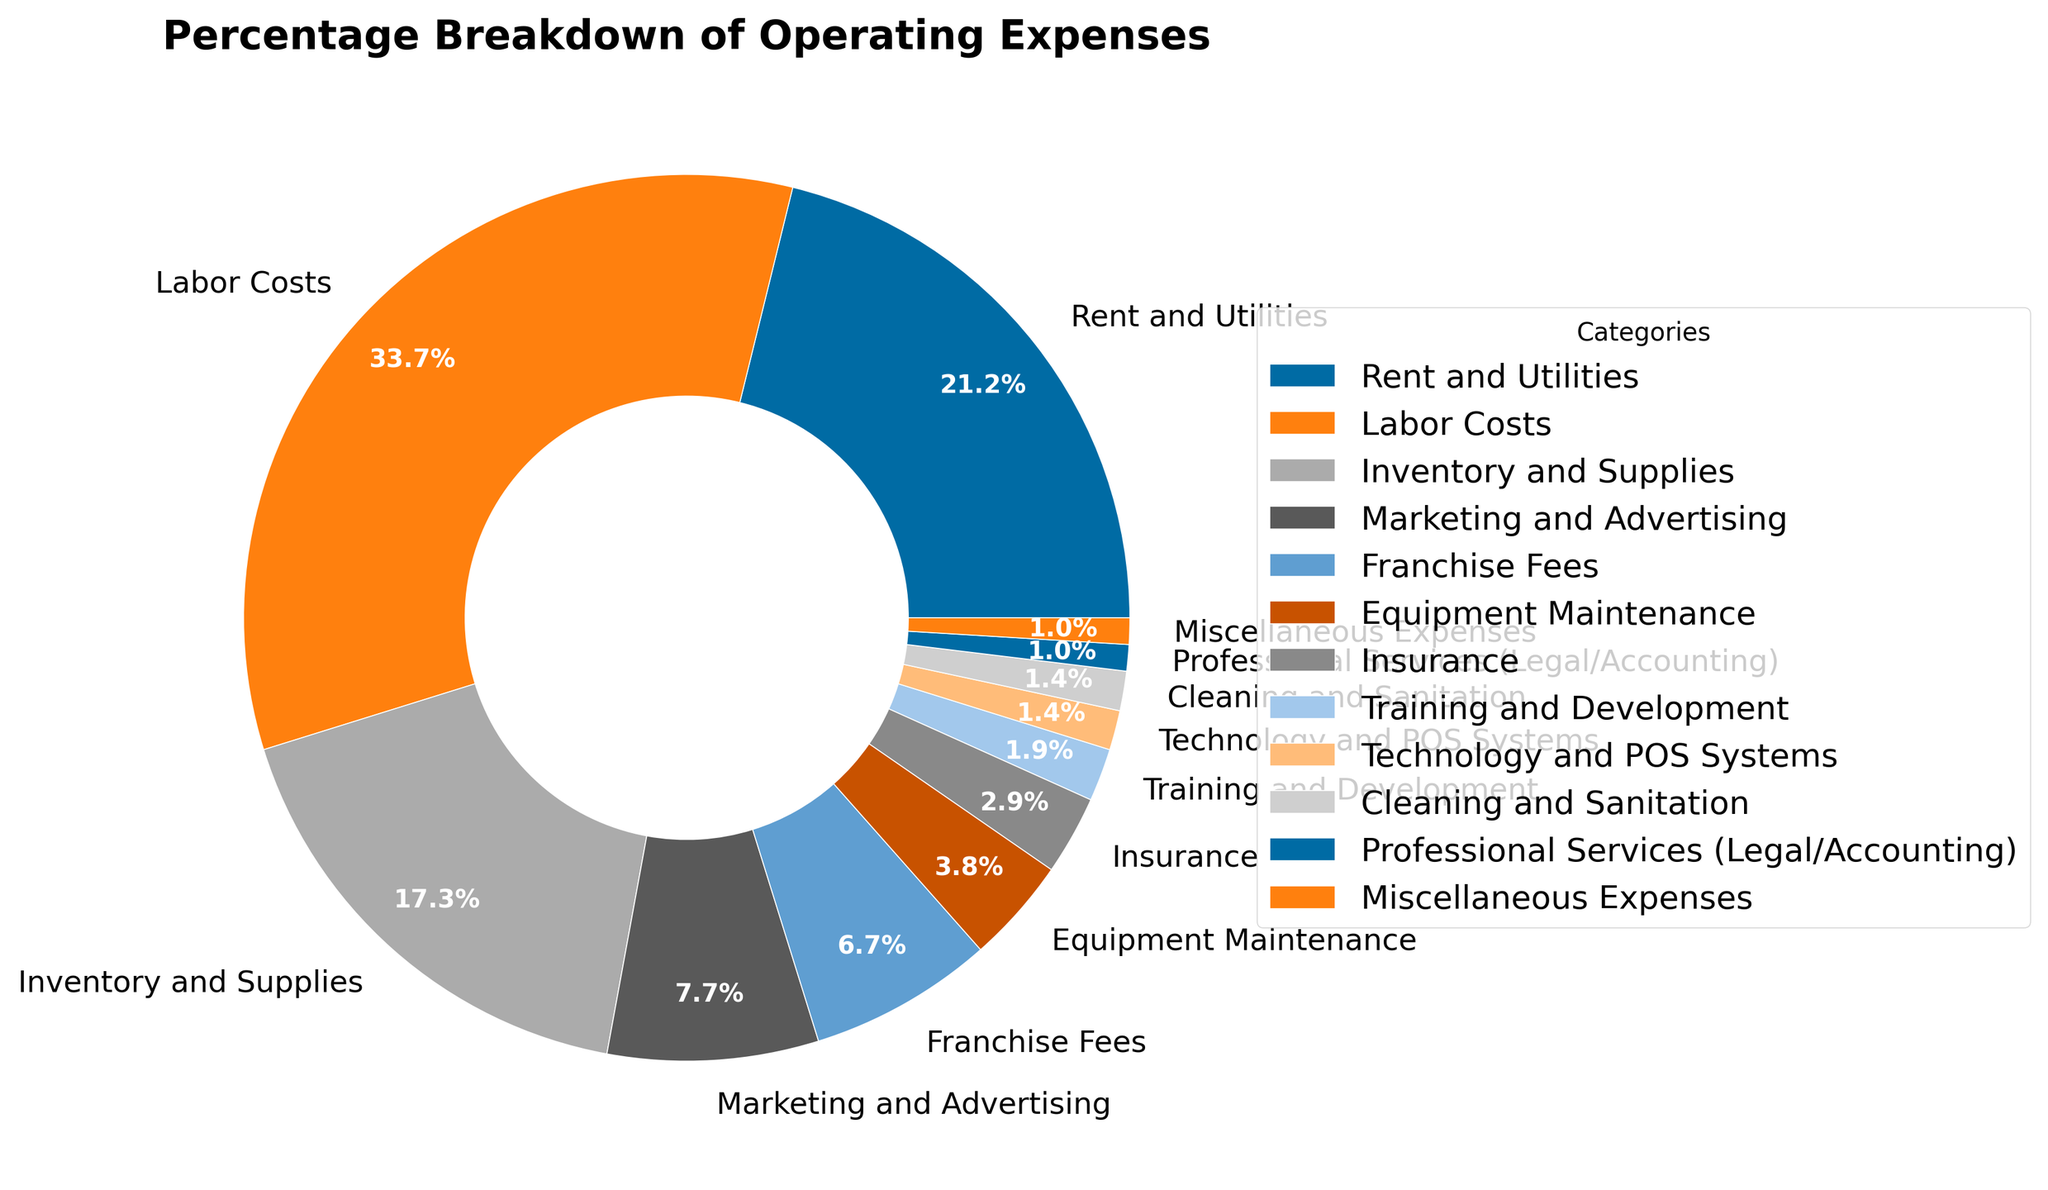What's the largest percentage in the pie chart? The largest segment in the pie chart represents "Labor Costs" at 35%. This can be identified since it is the largest wedge in the visual representation.
Answer: Labor Costs, 35% Which category has the smallest contribution to operating expenses? The smallest segments in the pie chart are "Training and Development" and "Professional Services (Legal/Accounting)" both at 1%. These can be identified by their smallest wedges.
Answer: Training and Development, Professional Services (Legal/Accounting), 1% How much higher is Labor Costs compared to Inventory and Supplies? "Labor Costs" is at 35%, and "Inventory and Supplies" is at 18%. The difference is 35% - 18% = 17%.
Answer: 17% What percentage of operating expenses are Rent and Utilities and Franchise Fees combined? "Rent and Utilities" is 22%, and "Franchise Fees" is 7%. Combined, they total 22% + 7% = 29%.
Answer: 29% What is the combined percentage of Technology and POS Systems, and Cleaning and Sanitation? "Technology and POS Systems" is 1.5%, and "Cleaning and Sanitation" is also 1.5%. Combined, they make 1.5% + 1.5% = 3%.
Answer: 3% Among Rent and Utilities, Marketing and Advertising, and Equipment Maintenance, which one has the highest percentage? "Rent and Utilities" has 22%, "Marketing and Advertising" has 8%, and "Equipment Maintenance" has 4%. "Rent and Utilities" has the highest percentage among these.
Answer: Rent and Utilities, 22% Which categories together make up exactly 10% of the total operating expenses? "Technology and POS Systems" has 1.5%, "Cleaning and Sanitation" has 1.5%, "Professional Services (Legal/Accounting)" has 1%, and "Miscellaneous Expenses" has 1%. Together they add 1.5% + 1.5% + 1% + 1% + 5% = 5% = 10%.
Answer: Technology and POS Systems, Cleaning and Sanitation, Professional Services (Legal/Accounting), Miscellaneous Expenses How does the expenditure on Marketing and Advertising compare to Insurance? "Marketing and Advertising" is 8%, while "Insurance" is 3%, meaning Marketing and Advertising expense is more than double the Insurance expense.
Answer: Marketing and Advertising, 8%, Insurance, 3% If the franchise decided to allocate an additional 2% of the budget to Technology and POS Systems, what would the new percentage be? Currently, "Technology and POS Systems" is 1.5%. Adding 2% more would make it 1.5% + 2% = 3.5%.
Answer: 3.5% 